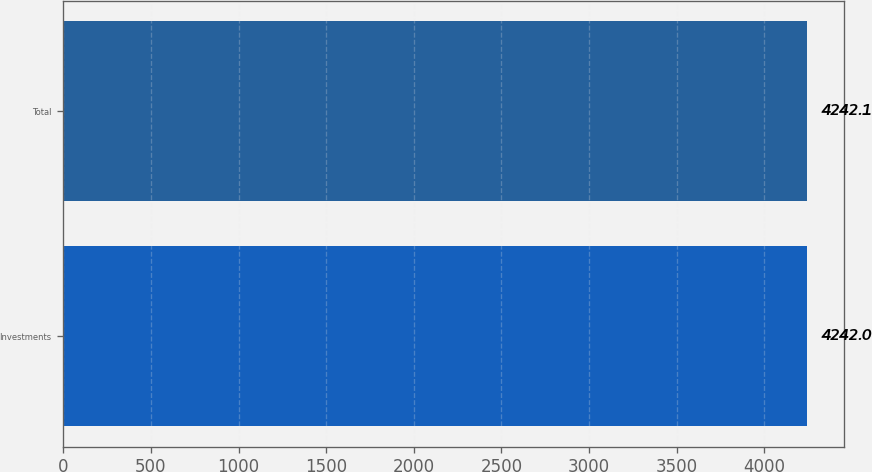Convert chart to OTSL. <chart><loc_0><loc_0><loc_500><loc_500><bar_chart><fcel>Investments<fcel>Total<nl><fcel>4242<fcel>4242.1<nl></chart> 